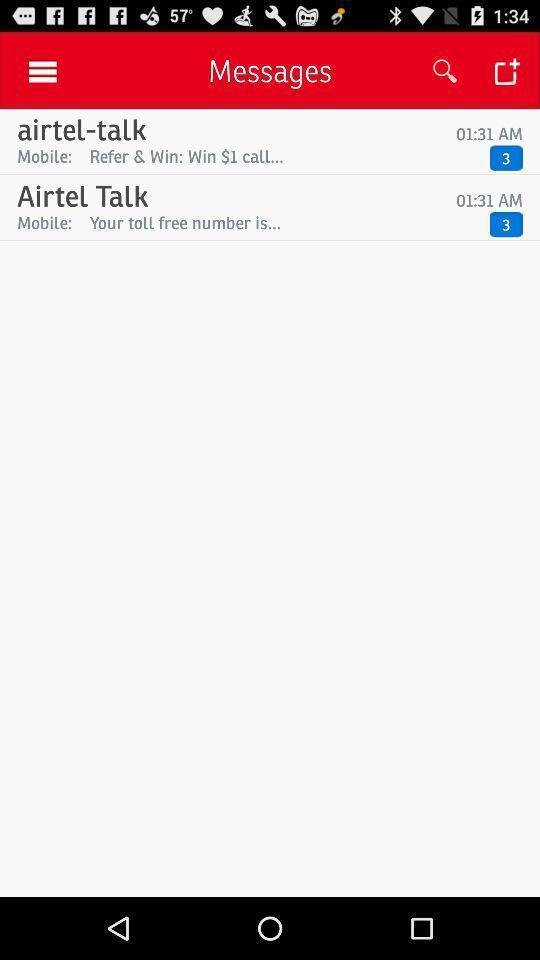Summarize the main components in this picture. Page that displays messages. 